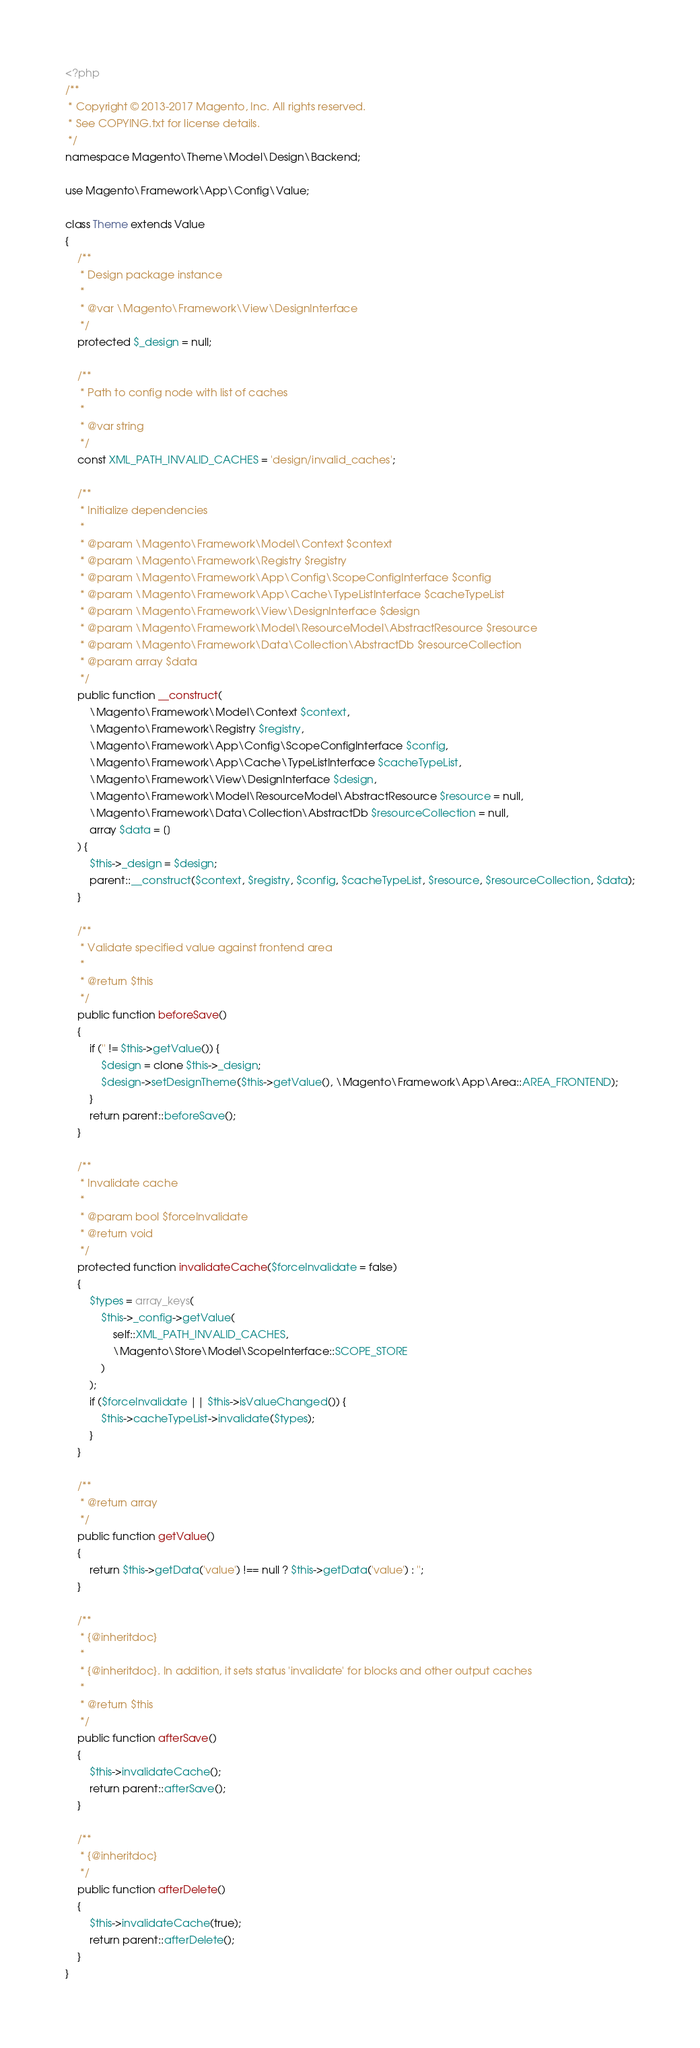Convert code to text. <code><loc_0><loc_0><loc_500><loc_500><_PHP_><?php
/**
 * Copyright © 2013-2017 Magento, Inc. All rights reserved.
 * See COPYING.txt for license details.
 */
namespace Magento\Theme\Model\Design\Backend;

use Magento\Framework\App\Config\Value;

class Theme extends Value
{
    /**
     * Design package instance
     *
     * @var \Magento\Framework\View\DesignInterface
     */
    protected $_design = null;

    /**
     * Path to config node with list of caches
     *
     * @var string
     */
    const XML_PATH_INVALID_CACHES = 'design/invalid_caches';

    /**
     * Initialize dependencies
     *
     * @param \Magento\Framework\Model\Context $context
     * @param \Magento\Framework\Registry $registry
     * @param \Magento\Framework\App\Config\ScopeConfigInterface $config
     * @param \Magento\Framework\App\Cache\TypeListInterface $cacheTypeList
     * @param \Magento\Framework\View\DesignInterface $design
     * @param \Magento\Framework\Model\ResourceModel\AbstractResource $resource
     * @param \Magento\Framework\Data\Collection\AbstractDb $resourceCollection
     * @param array $data
     */
    public function __construct(
        \Magento\Framework\Model\Context $context,
        \Magento\Framework\Registry $registry,
        \Magento\Framework\App\Config\ScopeConfigInterface $config,
        \Magento\Framework\App\Cache\TypeListInterface $cacheTypeList,
        \Magento\Framework\View\DesignInterface $design,
        \Magento\Framework\Model\ResourceModel\AbstractResource $resource = null,
        \Magento\Framework\Data\Collection\AbstractDb $resourceCollection = null,
        array $data = []
    ) {
        $this->_design = $design;
        parent::__construct($context, $registry, $config, $cacheTypeList, $resource, $resourceCollection, $data);
    }

    /**
     * Validate specified value against frontend area
     *
     * @return $this
     */
    public function beforeSave()
    {
        if ('' != $this->getValue()) {
            $design = clone $this->_design;
            $design->setDesignTheme($this->getValue(), \Magento\Framework\App\Area::AREA_FRONTEND);
        }
        return parent::beforeSave();
    }

    /**
     * Invalidate cache
     *
     * @param bool $forceInvalidate
     * @return void
     */
    protected function invalidateCache($forceInvalidate = false)
    {
        $types = array_keys(
            $this->_config->getValue(
                self::XML_PATH_INVALID_CACHES,
                \Magento\Store\Model\ScopeInterface::SCOPE_STORE
            )
        );
        if ($forceInvalidate || $this->isValueChanged()) {
            $this->cacheTypeList->invalidate($types);
        }
    }

    /**
     * @return array
     */
    public function getValue()
    {
        return $this->getData('value') !== null ? $this->getData('value') : '';
    }

    /**
     * {@inheritdoc}
     *
     * {@inheritdoc}. In addition, it sets status 'invalidate' for blocks and other output caches
     *
     * @return $this
     */
    public function afterSave()
    {
        $this->invalidateCache();
        return parent::afterSave();
    }

    /**
     * {@inheritdoc}
     */
    public function afterDelete()
    {
        $this->invalidateCache(true);
        return parent::afterDelete();
    }
}
</code> 